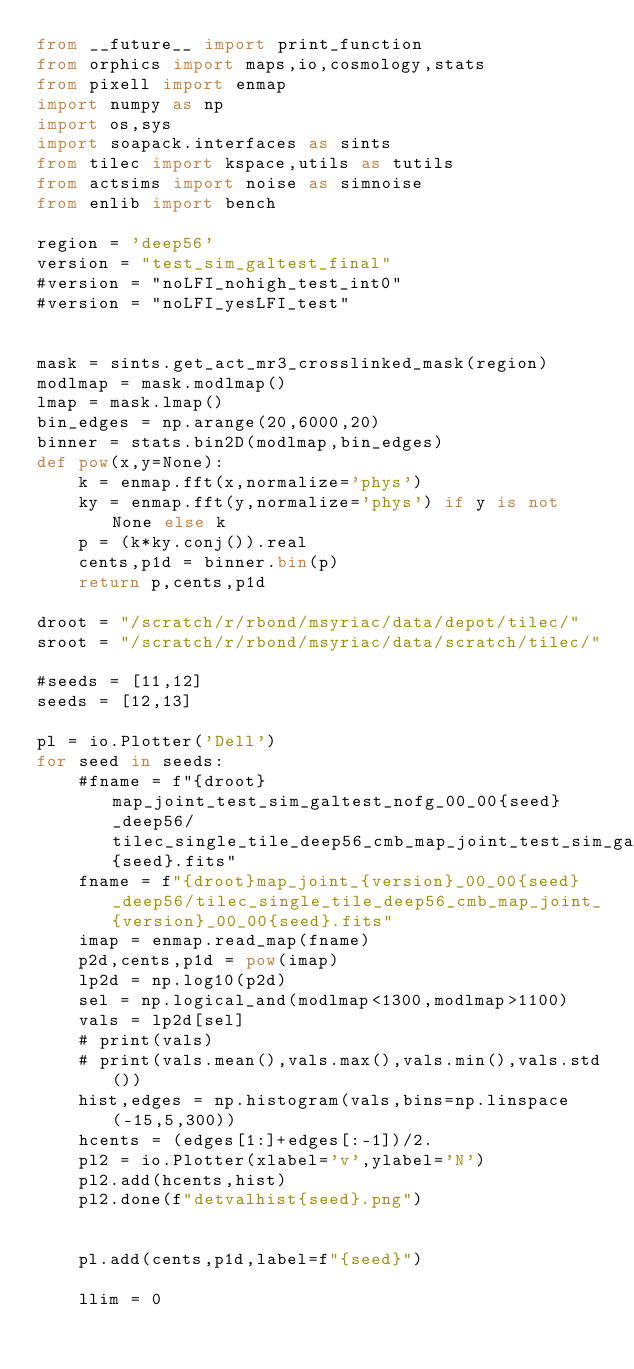<code> <loc_0><loc_0><loc_500><loc_500><_Python_>from __future__ import print_function
from orphics import maps,io,cosmology,stats
from pixell import enmap
import numpy as np
import os,sys
import soapack.interfaces as sints
from tilec import kspace,utils as tutils
from actsims import noise as simnoise
from enlib import bench

region = 'deep56'
version = "test_sim_galtest_final"
#version = "noLFI_nohigh_test_int0"
#version = "noLFI_yesLFI_test"


mask = sints.get_act_mr3_crosslinked_mask(region)
modlmap = mask.modlmap()
lmap = mask.lmap()
bin_edges = np.arange(20,6000,20)
binner = stats.bin2D(modlmap,bin_edges)
def pow(x,y=None):
    k = enmap.fft(x,normalize='phys')
    ky = enmap.fft(y,normalize='phys') if y is not None else k
    p = (k*ky.conj()).real
    cents,p1d = binner.bin(p)
    return p,cents,p1d

droot = "/scratch/r/rbond/msyriac/data/depot/tilec/"
sroot = "/scratch/r/rbond/msyriac/data/scratch/tilec/"

#seeds = [11,12]
seeds = [12,13]

pl = io.Plotter('Dell')
for seed in seeds:
    #fname = f"{droot}map_joint_test_sim_galtest_nofg_00_00{seed}_deep56/tilec_single_tile_deep56_cmb_map_joint_test_sim_galtest_nofg_00_00{seed}.fits"
    fname = f"{droot}map_joint_{version}_00_00{seed}_deep56/tilec_single_tile_deep56_cmb_map_joint_{version}_00_00{seed}.fits"
    imap = enmap.read_map(fname)
    p2d,cents,p1d = pow(imap)
    lp2d = np.log10(p2d)
    sel = np.logical_and(modlmap<1300,modlmap>1100)
    vals = lp2d[sel]
    # print(vals)
    # print(vals.mean(),vals.max(),vals.min(),vals.std())
    hist,edges = np.histogram(vals,bins=np.linspace(-15,5,300))
    hcents = (edges[1:]+edges[:-1])/2.
    pl2 = io.Plotter(xlabel='v',ylabel='N')
    pl2.add(hcents,hist)
    pl2.done(f"detvalhist{seed}.png")


    pl.add(cents,p1d,label=f"{seed}")
    
    llim = 0</code> 